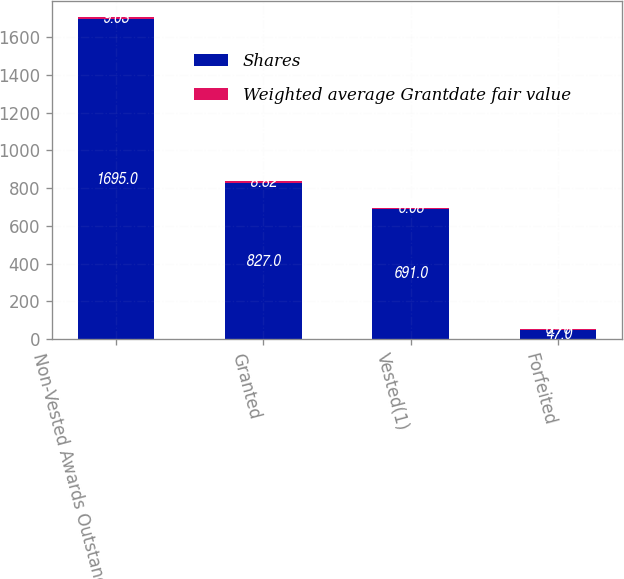Convert chart to OTSL. <chart><loc_0><loc_0><loc_500><loc_500><stacked_bar_chart><ecel><fcel>Non-Vested Awards Outstanding<fcel>Granted<fcel>Vested(1)<fcel>Forfeited<nl><fcel>Shares<fcel>1695<fcel>827<fcel>691<fcel>47<nl><fcel>Weighted average Grantdate fair value<fcel>9.03<fcel>8.82<fcel>6.08<fcel>6.76<nl></chart> 